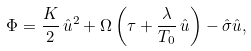Convert formula to latex. <formula><loc_0><loc_0><loc_500><loc_500>\Phi = \frac { K } { 2 } \, \hat { u } ^ { 2 } + \Omega \left ( \tau + \frac { \lambda } { T _ { 0 } } \, \hat { u } \right ) - \hat { \sigma } \hat { u } ,</formula> 